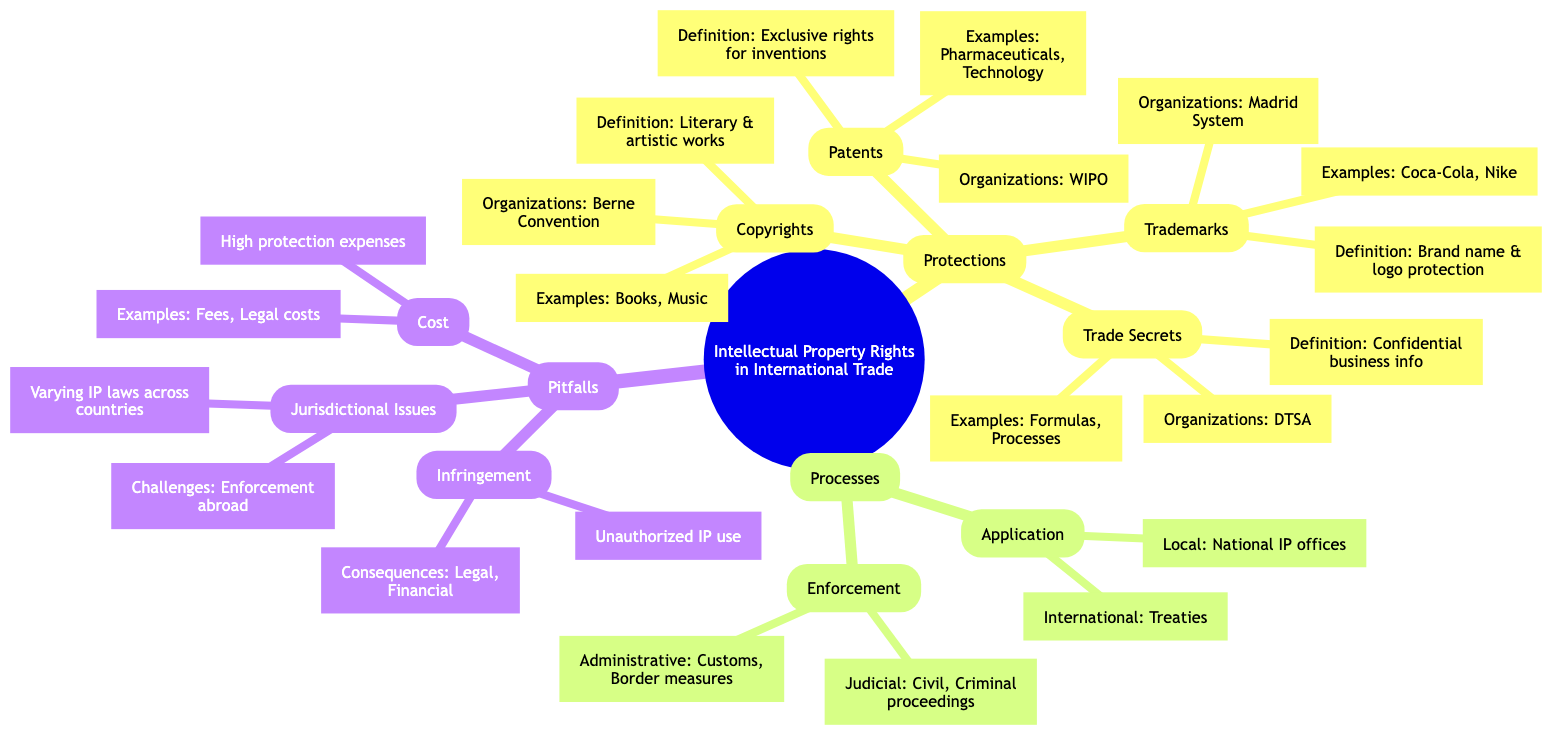What are the four types of protections under Intellectual Property Rights? The diagram lists four distinct protections: Patents, Trademarks, Copyrights, and Trade Secrets, which are categorized under the Protections node.
Answer: Patents, Trademarks, Copyrights, Trade Secrets What is the definition of Trade Secrets? The definition of Trade Secrets according to the diagram is "Protection of confidential business information," which is specifically highlighted under the Trade Secrets node.
Answer: Protection of confidential business information Which organization is associated with Copyrights? The diagram specifies that the Berne Convention is the organization related to Copyrights, showing the corresponding link under that protection type.
Answer: Berne Convention How many types of processes are shown in the diagram? The diagram delineates two main types of processes: Application and Enforcement, counting these as distinct process categories under the Processes node.
Answer: 2 What are the two application procedures outlined in the diagram? The diagram describes two procedures under the Application node: Local and International, clearly indicating the distinction and types of application approaches.
Answer: Local, International What is a consequence of IP infringement mentioned in the diagram? The consequences of IP infringement listed in the diagram include "Legal penalties" as a critical result, which is under the Infringement node within the Pitfalls category.
Answer: Legal penalties What are the two examples mentioned under Patents? According to the diagram, the examples provided under Patents are "Pharmaceuticals" and "Technology Products," which are listed directly under the Patents category.
Answer: Pharmaceuticals, Technology Products What challenges arise from jurisdictional issues in IP law? The diagram states that "Enforcing rights abroad" and "Navigating different legal systems" are challenges that stem from jurisdictional issues, which are specified under that pitfalls category.
Answer: Enforcing rights abroad, Navigating different legal systems What kind of enforcement methods are identified in the diagram? Two enforcement methods are presented in the diagram, namely Administrative and Judicial, categorized under the Enforcement node within Processes.
Answer: Administrative, Judicial 